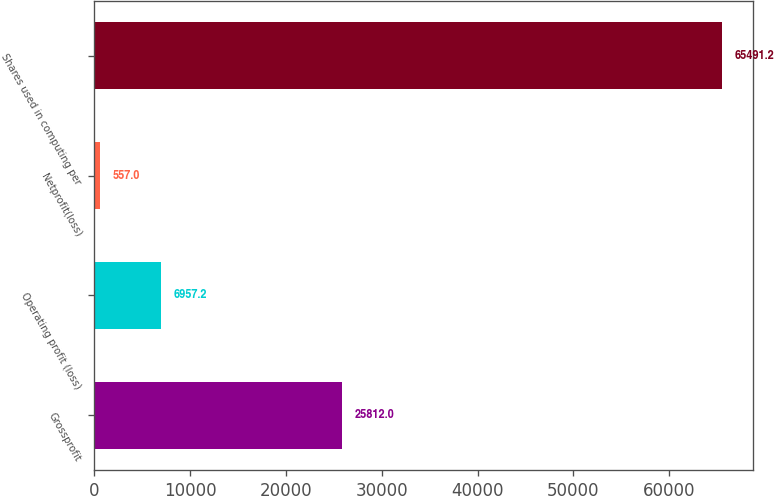Convert chart to OTSL. <chart><loc_0><loc_0><loc_500><loc_500><bar_chart><fcel>Grossprofit<fcel>Operating profit (loss)<fcel>Netprofit(loss)<fcel>Shares used in computing per<nl><fcel>25812<fcel>6957.2<fcel>557<fcel>65491.2<nl></chart> 